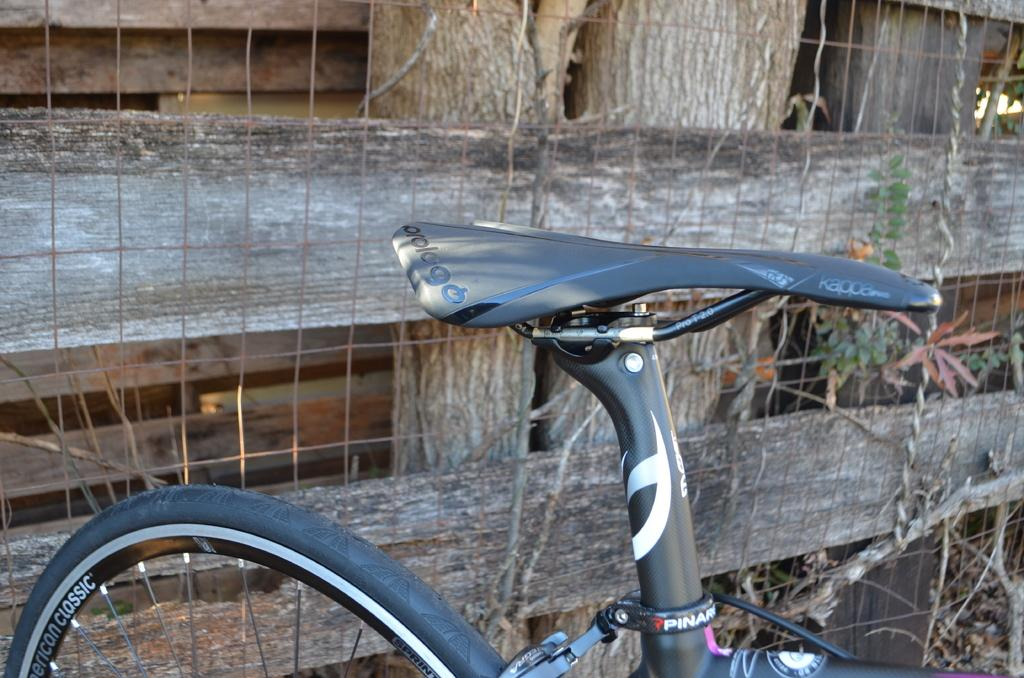What is the main object in the image? There is a bicycle in the image. What type of natural elements can be seen in the image? Tree trunks and plants are visible in the image. What type of barrier is present in the image? There is a wire fence in the image. What type of material is used for some objects in the image? There are wooden objects in the image. Where is the pail located in the image? There is no pail present in the image. What type of bread can be seen on the bicycle in the image? There is no loaf of bread present on the bicycle or anywhere in the image. 